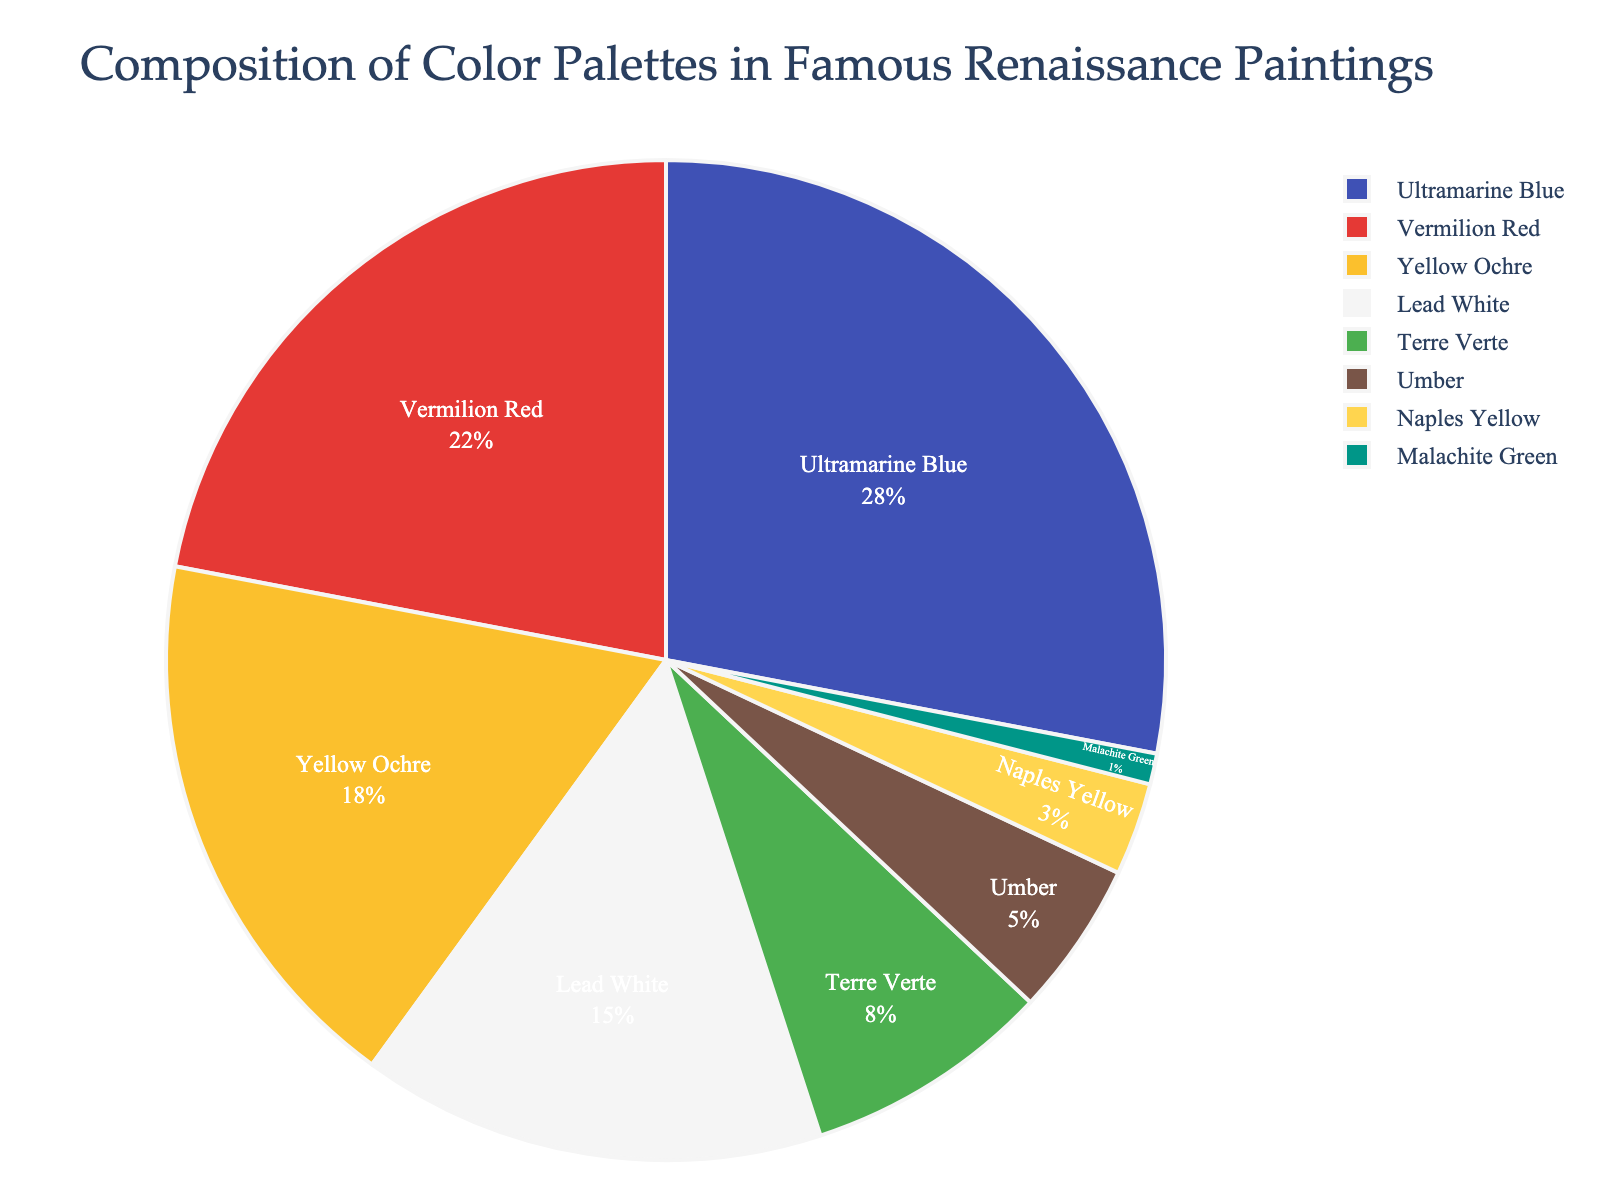What's the most frequently used color in Renaissance paintings according to the pie chart? From the pie chart, the color segment with the largest percentage represents the most frequently used color.
Answer: Ultramarine Blue What's the combined percentage of Yellow Ochre and Lead White? The pie chart shows Yellow Ochre at 18% and Lead White at 15%. Adding these two values gives 18 + 15 = 33%.
Answer: 33% Which color is more prevalent, Vermilion Red or Terre Verte? Comparing the percentages from the pie chart, Vermilion Red has 22% whereas Terre Verte has 8%. 22% is greater than 8%.
Answer: Vermilion Red How much more prevalent is Ultramarine Blue compared to Umber? The pie chart shows Ultramarine Blue at 28% and Umber at 5%. The difference is calculated by subtracting 5 from 28, giving 28 - 5 = 23%.
Answer: 23% What's the total percentage of colors other than Ultramarine Blue? Ultramarine Blue is 28%. Subtracting this from 100% gives 100 - 28 = 72%.
Answer: 72% Which two colors have the smallest percentages? From the pie chart, Naples Yellow has 3% and Malachite Green has 1%, which are the smallest percentages among all colors.
Answer: Naples Yellow and Malachite Green What's the difference in percentage between Vermilion Red and Lead White? Vermilion Red is 22% and Lead White is 15%. The difference is calculated by subtracting 15 from 22, giving 22 - 15 = 7%.
Answer: 7% Which color occupies roughly one-fourth of the pie chart? Ultramarine Blue occupies 28% of the pie chart, which is approximately one-fourth (25%).
Answer: Ultramarine Blue How much percentage do Earth tones (Yellow Ochre, Terre Verte, Umber) occupy together? Yellow Ochre is 18%, Terre Verte is 8%, and Umber is 5%. Adding these values gives 18 + 8 + 5 = 31%.
Answer: 31% What's the ratio of Lead White to Malachite Green in the composition? Lead White is 15% and Malachite Green is 1%. The ratio is calculated as 15:1.
Answer: 15:1 